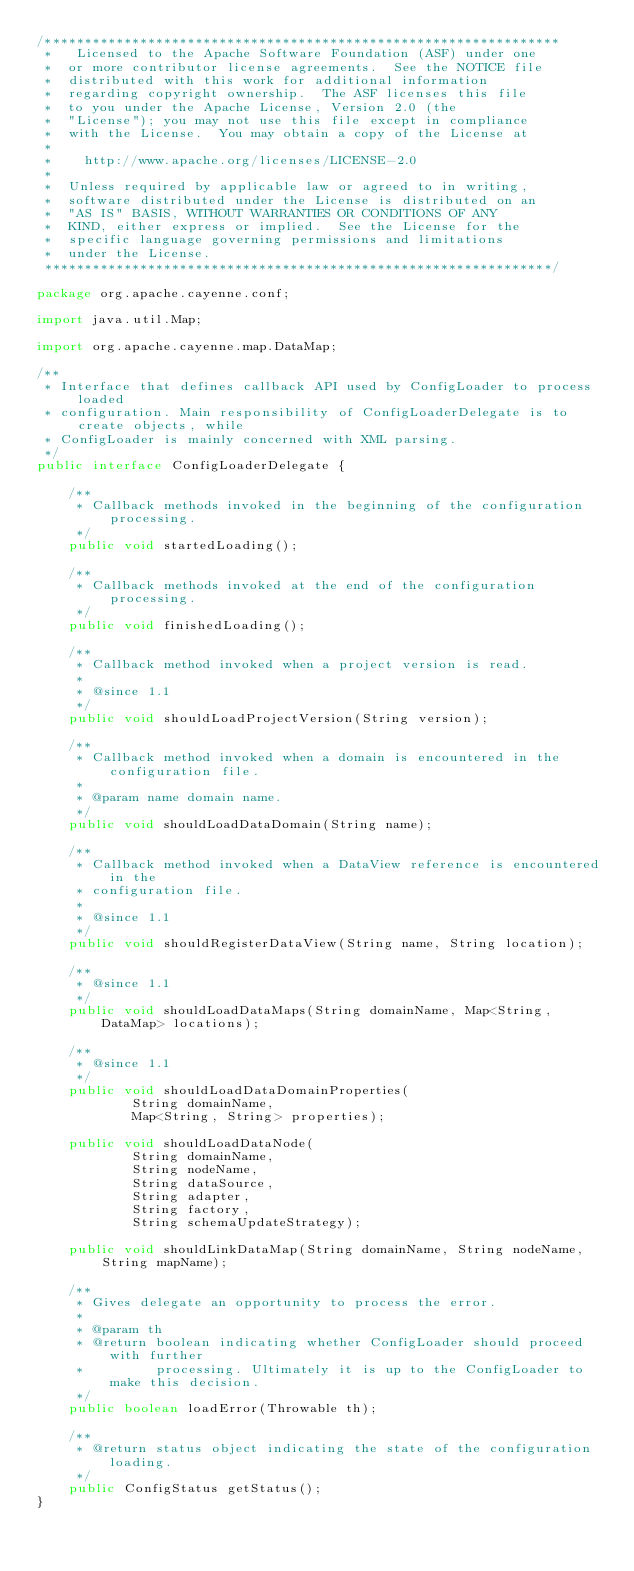Convert code to text. <code><loc_0><loc_0><loc_500><loc_500><_Java_>/*****************************************************************
 *   Licensed to the Apache Software Foundation (ASF) under one
 *  or more contributor license agreements.  See the NOTICE file
 *  distributed with this work for additional information
 *  regarding copyright ownership.  The ASF licenses this file
 *  to you under the Apache License, Version 2.0 (the
 *  "License"); you may not use this file except in compliance
 *  with the License.  You may obtain a copy of the License at
 *
 *    http://www.apache.org/licenses/LICENSE-2.0
 *
 *  Unless required by applicable law or agreed to in writing,
 *  software distributed under the License is distributed on an
 *  "AS IS" BASIS, WITHOUT WARRANTIES OR CONDITIONS OF ANY
 *  KIND, either express or implied.  See the License for the
 *  specific language governing permissions and limitations
 *  under the License.
 ****************************************************************/

package org.apache.cayenne.conf;

import java.util.Map;

import org.apache.cayenne.map.DataMap;

/**
 * Interface that defines callback API used by ConfigLoader to process loaded
 * configuration. Main responsibility of ConfigLoaderDelegate is to create objects, while
 * ConfigLoader is mainly concerned with XML parsing.
 */
public interface ConfigLoaderDelegate {

    /**
     * Callback methods invoked in the beginning of the configuration processing.
     */
    public void startedLoading();

    /**
     * Callback methods invoked at the end of the configuration processing.
     */
    public void finishedLoading();

    /**
     * Callback method invoked when a project version is read.
     * 
     * @since 1.1
     */
    public void shouldLoadProjectVersion(String version);

    /**
     * Callback method invoked when a domain is encountered in the configuration file.
     * 
     * @param name domain name.
     */
    public void shouldLoadDataDomain(String name);

    /**
     * Callback method invoked when a DataView reference is encountered in the
     * configuration file.
     * 
     * @since 1.1
     */
    public void shouldRegisterDataView(String name, String location);

    /**
     * @since 1.1
     */
    public void shouldLoadDataMaps(String domainName, Map<String, DataMap> locations);

    /**
     * @since 1.1
     */
    public void shouldLoadDataDomainProperties(
            String domainName,
            Map<String, String> properties);

    public void shouldLoadDataNode(
            String domainName,
            String nodeName,
            String dataSource,
            String adapter,
            String factory,
            String schemaUpdateStrategy);

    public void shouldLinkDataMap(String domainName, String nodeName, String mapName);

    /**
     * Gives delegate an opportunity to process the error.
     * 
     * @param th
     * @return boolean indicating whether ConfigLoader should proceed with further
     *         processing. Ultimately it is up to the ConfigLoader to make this decision.
     */
    public boolean loadError(Throwable th);

    /**
     * @return status object indicating the state of the configuration loading.
     */
    public ConfigStatus getStatus();
}
</code> 